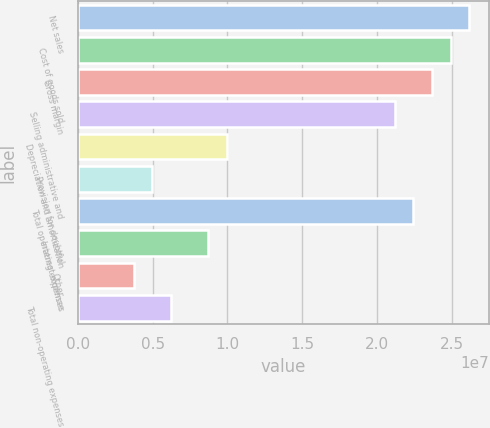Convert chart. <chart><loc_0><loc_0><loc_500><loc_500><bar_chart><fcel>Net sales<fcel>Cost of goods sold<fcel>Gross margin<fcel>Selling administrative and<fcel>Depreciation and amortization<fcel>Provision for doubtful<fcel>Total operating expenses<fcel>Interest expense<fcel>Other<fcel>Total non-operating expenses<nl><fcel>2.61636e+07<fcel>2.49178e+07<fcel>2.36719e+07<fcel>2.11801e+07<fcel>9.9671e+06<fcel>4.98355e+06<fcel>2.2426e+07<fcel>8.72121e+06<fcel>3.73767e+06<fcel>6.22944e+06<nl></chart> 